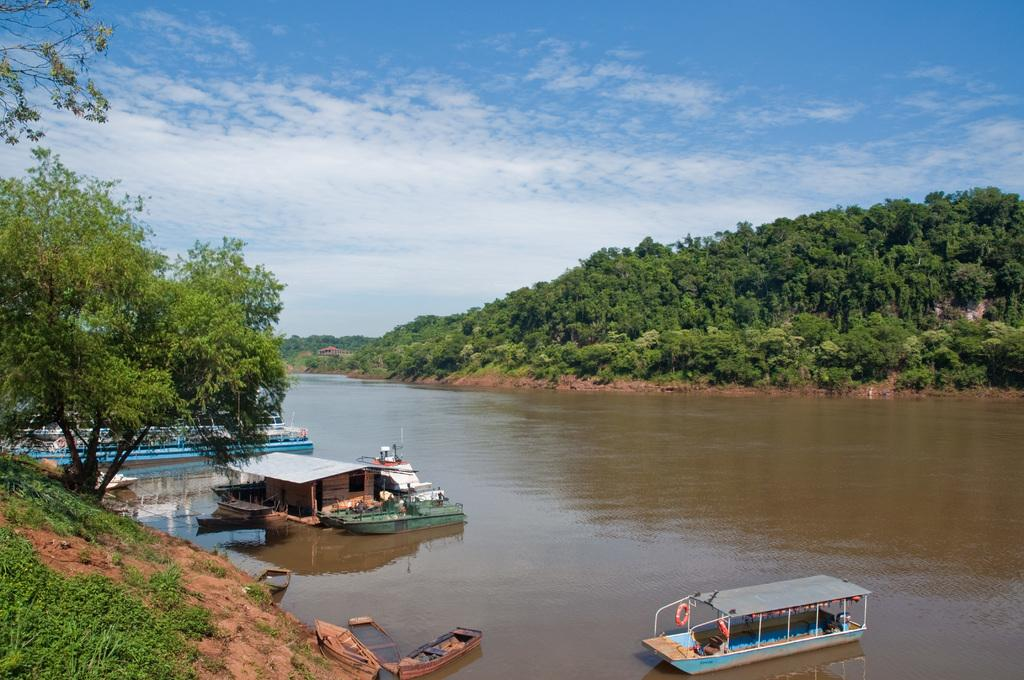What type of natural feature is visible in the image? There is a river in the image. What is in the river? There are boats in the river. What other geographical features can be seen in the image? There are mountains in the image. What is growing on the mountains? Trees are present on the mountains. What is visible in the sky? There are clouds in the sky. What is the purpose of the day in the image? The image does not depict a specific day or event, so it is not possible to determine the purpose of the day. 